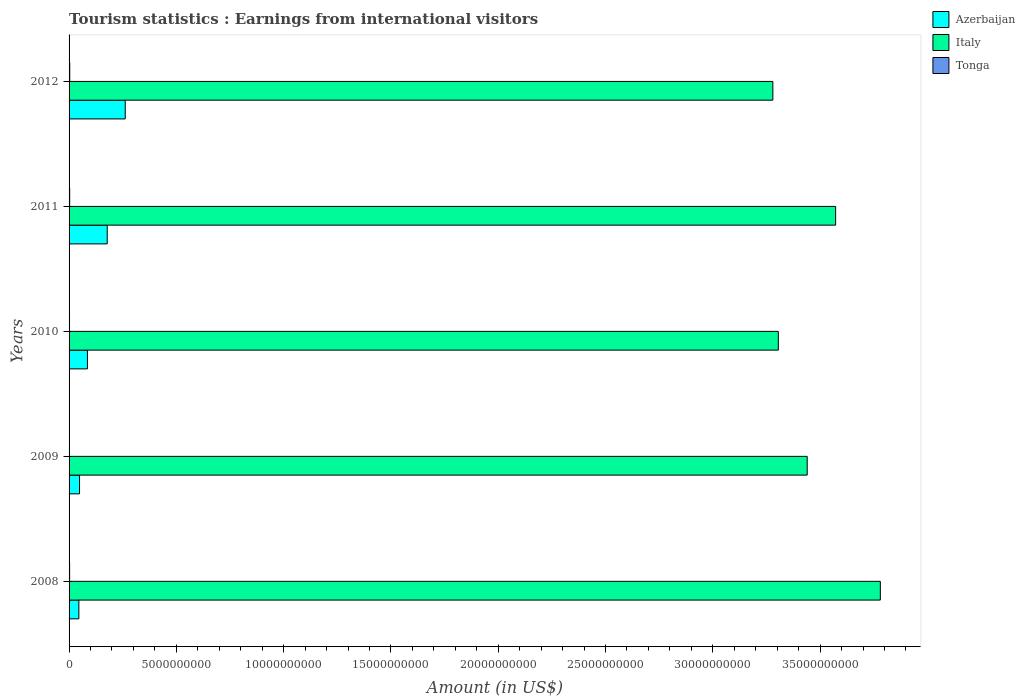How many different coloured bars are there?
Provide a succinct answer. 3. How many groups of bars are there?
Your answer should be very brief. 5. Are the number of bars per tick equal to the number of legend labels?
Provide a short and direct response. Yes. What is the label of the 4th group of bars from the top?
Make the answer very short. 2009. In how many cases, is the number of bars for a given year not equal to the number of legend labels?
Offer a very short reply. 0. What is the earnings from international visitors in Italy in 2010?
Ensure brevity in your answer.  3.31e+1. Across all years, what is the maximum earnings from international visitors in Italy?
Keep it short and to the point. 3.78e+1. Across all years, what is the minimum earnings from international visitors in Tonga?
Your answer should be compact. 1.91e+07. In which year was the earnings from international visitors in Italy maximum?
Your answer should be compact. 2008. What is the total earnings from international visitors in Azerbaijan in the graph?
Your response must be concise. 6.20e+09. What is the difference between the earnings from international visitors in Tonga in 2009 and that in 2010?
Your response must be concise. -1.30e+06. What is the difference between the earnings from international visitors in Azerbaijan in 2011 and the earnings from international visitors in Italy in 2008?
Provide a short and direct response. -3.60e+1. What is the average earnings from international visitors in Italy per year?
Give a very brief answer. 3.48e+1. In the year 2012, what is the difference between the earnings from international visitors in Italy and earnings from international visitors in Azerbaijan?
Provide a succinct answer. 3.02e+1. In how many years, is the earnings from international visitors in Tonga greater than 1000000000 US$?
Give a very brief answer. 0. What is the ratio of the earnings from international visitors in Tonga in 2010 to that in 2011?
Ensure brevity in your answer.  0.73. Is the earnings from international visitors in Tonga in 2009 less than that in 2010?
Your answer should be very brief. Yes. Is the difference between the earnings from international visitors in Italy in 2010 and 2011 greater than the difference between the earnings from international visitors in Azerbaijan in 2010 and 2011?
Your response must be concise. No. What is the difference between the highest and the second highest earnings from international visitors in Tonga?
Your response must be concise. 3.50e+06. What is the difference between the highest and the lowest earnings from international visitors in Azerbaijan?
Your response must be concise. 2.16e+09. Is the sum of the earnings from international visitors in Tonga in 2011 and 2012 greater than the maximum earnings from international visitors in Italy across all years?
Make the answer very short. No. What does the 1st bar from the top in 2009 represents?
Your response must be concise. Tonga. What does the 1st bar from the bottom in 2012 represents?
Make the answer very short. Azerbaijan. How many bars are there?
Provide a short and direct response. 15. Are all the bars in the graph horizontal?
Give a very brief answer. Yes. How many years are there in the graph?
Provide a short and direct response. 5. Are the values on the major ticks of X-axis written in scientific E-notation?
Make the answer very short. No. Does the graph contain any zero values?
Give a very brief answer. No. Where does the legend appear in the graph?
Your answer should be compact. Top right. How many legend labels are there?
Your answer should be very brief. 3. What is the title of the graph?
Your answer should be very brief. Tourism statistics : Earnings from international visitors. Does "Egypt, Arab Rep." appear as one of the legend labels in the graph?
Provide a succinct answer. No. What is the label or title of the Y-axis?
Offer a very short reply. Years. What is the Amount (in US$) of Azerbaijan in 2008?
Provide a succinct answer. 4.56e+08. What is the Amount (in US$) in Italy in 2008?
Your response must be concise. 3.78e+1. What is the Amount (in US$) in Tonga in 2008?
Offer a terse response. 2.51e+07. What is the Amount (in US$) in Azerbaijan in 2009?
Ensure brevity in your answer.  4.88e+08. What is the Amount (in US$) in Italy in 2009?
Your answer should be very brief. 3.44e+1. What is the Amount (in US$) of Tonga in 2009?
Provide a short and direct response. 1.91e+07. What is the Amount (in US$) of Azerbaijan in 2010?
Provide a succinct answer. 8.56e+08. What is the Amount (in US$) in Italy in 2010?
Make the answer very short. 3.31e+1. What is the Amount (in US$) of Tonga in 2010?
Your answer should be compact. 2.04e+07. What is the Amount (in US$) of Azerbaijan in 2011?
Offer a terse response. 1.78e+09. What is the Amount (in US$) in Italy in 2011?
Give a very brief answer. 3.57e+1. What is the Amount (in US$) of Tonga in 2011?
Provide a succinct answer. 2.78e+07. What is the Amount (in US$) in Azerbaijan in 2012?
Your answer should be very brief. 2.62e+09. What is the Amount (in US$) of Italy in 2012?
Offer a terse response. 3.28e+1. What is the Amount (in US$) of Tonga in 2012?
Your answer should be compact. 3.13e+07. Across all years, what is the maximum Amount (in US$) of Azerbaijan?
Ensure brevity in your answer.  2.62e+09. Across all years, what is the maximum Amount (in US$) in Italy?
Give a very brief answer. 3.78e+1. Across all years, what is the maximum Amount (in US$) in Tonga?
Make the answer very short. 3.13e+07. Across all years, what is the minimum Amount (in US$) in Azerbaijan?
Your answer should be compact. 4.56e+08. Across all years, what is the minimum Amount (in US$) of Italy?
Offer a terse response. 3.28e+1. Across all years, what is the minimum Amount (in US$) of Tonga?
Your response must be concise. 1.91e+07. What is the total Amount (in US$) of Azerbaijan in the graph?
Make the answer very short. 6.20e+09. What is the total Amount (in US$) in Italy in the graph?
Keep it short and to the point. 1.74e+11. What is the total Amount (in US$) in Tonga in the graph?
Your answer should be very brief. 1.24e+08. What is the difference between the Amount (in US$) in Azerbaijan in 2008 and that in 2009?
Give a very brief answer. -3.20e+07. What is the difference between the Amount (in US$) in Italy in 2008 and that in 2009?
Your response must be concise. 3.41e+09. What is the difference between the Amount (in US$) in Tonga in 2008 and that in 2009?
Provide a short and direct response. 6.00e+06. What is the difference between the Amount (in US$) of Azerbaijan in 2008 and that in 2010?
Provide a succinct answer. -4.00e+08. What is the difference between the Amount (in US$) of Italy in 2008 and that in 2010?
Your response must be concise. 4.75e+09. What is the difference between the Amount (in US$) in Tonga in 2008 and that in 2010?
Provide a short and direct response. 4.70e+06. What is the difference between the Amount (in US$) of Azerbaijan in 2008 and that in 2011?
Make the answer very short. -1.32e+09. What is the difference between the Amount (in US$) in Italy in 2008 and that in 2011?
Provide a short and direct response. 2.08e+09. What is the difference between the Amount (in US$) of Tonga in 2008 and that in 2011?
Provide a short and direct response. -2.70e+06. What is the difference between the Amount (in US$) of Azerbaijan in 2008 and that in 2012?
Offer a very short reply. -2.16e+09. What is the difference between the Amount (in US$) in Italy in 2008 and that in 2012?
Make the answer very short. 5.01e+09. What is the difference between the Amount (in US$) of Tonga in 2008 and that in 2012?
Make the answer very short. -6.20e+06. What is the difference between the Amount (in US$) in Azerbaijan in 2009 and that in 2010?
Provide a short and direct response. -3.68e+08. What is the difference between the Amount (in US$) of Italy in 2009 and that in 2010?
Offer a terse response. 1.35e+09. What is the difference between the Amount (in US$) in Tonga in 2009 and that in 2010?
Ensure brevity in your answer.  -1.30e+06. What is the difference between the Amount (in US$) of Azerbaijan in 2009 and that in 2011?
Make the answer very short. -1.29e+09. What is the difference between the Amount (in US$) of Italy in 2009 and that in 2011?
Give a very brief answer. -1.32e+09. What is the difference between the Amount (in US$) of Tonga in 2009 and that in 2011?
Provide a short and direct response. -8.70e+06. What is the difference between the Amount (in US$) in Azerbaijan in 2009 and that in 2012?
Provide a short and direct response. -2.13e+09. What is the difference between the Amount (in US$) of Italy in 2009 and that in 2012?
Your answer should be compact. 1.60e+09. What is the difference between the Amount (in US$) of Tonga in 2009 and that in 2012?
Your answer should be compact. -1.22e+07. What is the difference between the Amount (in US$) of Azerbaijan in 2010 and that in 2011?
Offer a very short reply. -9.22e+08. What is the difference between the Amount (in US$) in Italy in 2010 and that in 2011?
Provide a succinct answer. -2.67e+09. What is the difference between the Amount (in US$) in Tonga in 2010 and that in 2011?
Ensure brevity in your answer.  -7.40e+06. What is the difference between the Amount (in US$) of Azerbaijan in 2010 and that in 2012?
Give a very brief answer. -1.76e+09. What is the difference between the Amount (in US$) of Italy in 2010 and that in 2012?
Your answer should be compact. 2.55e+08. What is the difference between the Amount (in US$) in Tonga in 2010 and that in 2012?
Provide a succinct answer. -1.09e+07. What is the difference between the Amount (in US$) in Azerbaijan in 2011 and that in 2012?
Ensure brevity in your answer.  -8.39e+08. What is the difference between the Amount (in US$) of Italy in 2011 and that in 2012?
Your answer should be very brief. 2.93e+09. What is the difference between the Amount (in US$) in Tonga in 2011 and that in 2012?
Provide a succinct answer. -3.50e+06. What is the difference between the Amount (in US$) of Azerbaijan in 2008 and the Amount (in US$) of Italy in 2009?
Give a very brief answer. -3.39e+1. What is the difference between the Amount (in US$) of Azerbaijan in 2008 and the Amount (in US$) of Tonga in 2009?
Give a very brief answer. 4.37e+08. What is the difference between the Amount (in US$) in Italy in 2008 and the Amount (in US$) in Tonga in 2009?
Provide a succinct answer. 3.78e+1. What is the difference between the Amount (in US$) in Azerbaijan in 2008 and the Amount (in US$) in Italy in 2010?
Offer a very short reply. -3.26e+1. What is the difference between the Amount (in US$) in Azerbaijan in 2008 and the Amount (in US$) in Tonga in 2010?
Provide a succinct answer. 4.36e+08. What is the difference between the Amount (in US$) of Italy in 2008 and the Amount (in US$) of Tonga in 2010?
Keep it short and to the point. 3.78e+1. What is the difference between the Amount (in US$) in Azerbaijan in 2008 and the Amount (in US$) in Italy in 2011?
Give a very brief answer. -3.53e+1. What is the difference between the Amount (in US$) in Azerbaijan in 2008 and the Amount (in US$) in Tonga in 2011?
Offer a very short reply. 4.28e+08. What is the difference between the Amount (in US$) of Italy in 2008 and the Amount (in US$) of Tonga in 2011?
Your answer should be compact. 3.78e+1. What is the difference between the Amount (in US$) of Azerbaijan in 2008 and the Amount (in US$) of Italy in 2012?
Your answer should be very brief. -3.23e+1. What is the difference between the Amount (in US$) in Azerbaijan in 2008 and the Amount (in US$) in Tonga in 2012?
Your answer should be compact. 4.25e+08. What is the difference between the Amount (in US$) in Italy in 2008 and the Amount (in US$) in Tonga in 2012?
Ensure brevity in your answer.  3.78e+1. What is the difference between the Amount (in US$) of Azerbaijan in 2009 and the Amount (in US$) of Italy in 2010?
Offer a terse response. -3.26e+1. What is the difference between the Amount (in US$) of Azerbaijan in 2009 and the Amount (in US$) of Tonga in 2010?
Provide a short and direct response. 4.68e+08. What is the difference between the Amount (in US$) of Italy in 2009 and the Amount (in US$) of Tonga in 2010?
Keep it short and to the point. 3.44e+1. What is the difference between the Amount (in US$) of Azerbaijan in 2009 and the Amount (in US$) of Italy in 2011?
Make the answer very short. -3.52e+1. What is the difference between the Amount (in US$) in Azerbaijan in 2009 and the Amount (in US$) in Tonga in 2011?
Ensure brevity in your answer.  4.60e+08. What is the difference between the Amount (in US$) of Italy in 2009 and the Amount (in US$) of Tonga in 2011?
Your answer should be compact. 3.44e+1. What is the difference between the Amount (in US$) of Azerbaijan in 2009 and the Amount (in US$) of Italy in 2012?
Give a very brief answer. -3.23e+1. What is the difference between the Amount (in US$) of Azerbaijan in 2009 and the Amount (in US$) of Tonga in 2012?
Offer a terse response. 4.57e+08. What is the difference between the Amount (in US$) in Italy in 2009 and the Amount (in US$) in Tonga in 2012?
Offer a terse response. 3.44e+1. What is the difference between the Amount (in US$) of Azerbaijan in 2010 and the Amount (in US$) of Italy in 2011?
Your answer should be compact. -3.49e+1. What is the difference between the Amount (in US$) of Azerbaijan in 2010 and the Amount (in US$) of Tonga in 2011?
Make the answer very short. 8.28e+08. What is the difference between the Amount (in US$) in Italy in 2010 and the Amount (in US$) in Tonga in 2011?
Keep it short and to the point. 3.30e+1. What is the difference between the Amount (in US$) in Azerbaijan in 2010 and the Amount (in US$) in Italy in 2012?
Make the answer very short. -3.19e+1. What is the difference between the Amount (in US$) of Azerbaijan in 2010 and the Amount (in US$) of Tonga in 2012?
Offer a terse response. 8.25e+08. What is the difference between the Amount (in US$) in Italy in 2010 and the Amount (in US$) in Tonga in 2012?
Make the answer very short. 3.30e+1. What is the difference between the Amount (in US$) in Azerbaijan in 2011 and the Amount (in US$) in Italy in 2012?
Give a very brief answer. -3.10e+1. What is the difference between the Amount (in US$) of Azerbaijan in 2011 and the Amount (in US$) of Tonga in 2012?
Your answer should be compact. 1.75e+09. What is the difference between the Amount (in US$) of Italy in 2011 and the Amount (in US$) of Tonga in 2012?
Offer a terse response. 3.57e+1. What is the average Amount (in US$) of Azerbaijan per year?
Make the answer very short. 1.24e+09. What is the average Amount (in US$) in Italy per year?
Keep it short and to the point. 3.48e+1. What is the average Amount (in US$) in Tonga per year?
Ensure brevity in your answer.  2.47e+07. In the year 2008, what is the difference between the Amount (in US$) of Azerbaijan and Amount (in US$) of Italy?
Offer a terse response. -3.74e+1. In the year 2008, what is the difference between the Amount (in US$) of Azerbaijan and Amount (in US$) of Tonga?
Make the answer very short. 4.31e+08. In the year 2008, what is the difference between the Amount (in US$) of Italy and Amount (in US$) of Tonga?
Your response must be concise. 3.78e+1. In the year 2009, what is the difference between the Amount (in US$) of Azerbaijan and Amount (in US$) of Italy?
Provide a succinct answer. -3.39e+1. In the year 2009, what is the difference between the Amount (in US$) of Azerbaijan and Amount (in US$) of Tonga?
Your response must be concise. 4.69e+08. In the year 2009, what is the difference between the Amount (in US$) in Italy and Amount (in US$) in Tonga?
Provide a short and direct response. 3.44e+1. In the year 2010, what is the difference between the Amount (in US$) of Azerbaijan and Amount (in US$) of Italy?
Keep it short and to the point. -3.22e+1. In the year 2010, what is the difference between the Amount (in US$) of Azerbaijan and Amount (in US$) of Tonga?
Offer a very short reply. 8.36e+08. In the year 2010, what is the difference between the Amount (in US$) in Italy and Amount (in US$) in Tonga?
Offer a very short reply. 3.30e+1. In the year 2011, what is the difference between the Amount (in US$) of Azerbaijan and Amount (in US$) of Italy?
Make the answer very short. -3.39e+1. In the year 2011, what is the difference between the Amount (in US$) in Azerbaijan and Amount (in US$) in Tonga?
Provide a short and direct response. 1.75e+09. In the year 2011, what is the difference between the Amount (in US$) of Italy and Amount (in US$) of Tonga?
Your answer should be very brief. 3.57e+1. In the year 2012, what is the difference between the Amount (in US$) of Azerbaijan and Amount (in US$) of Italy?
Keep it short and to the point. -3.02e+1. In the year 2012, what is the difference between the Amount (in US$) in Azerbaijan and Amount (in US$) in Tonga?
Give a very brief answer. 2.59e+09. In the year 2012, what is the difference between the Amount (in US$) of Italy and Amount (in US$) of Tonga?
Make the answer very short. 3.28e+1. What is the ratio of the Amount (in US$) of Azerbaijan in 2008 to that in 2009?
Your response must be concise. 0.93. What is the ratio of the Amount (in US$) in Italy in 2008 to that in 2009?
Offer a terse response. 1.1. What is the ratio of the Amount (in US$) of Tonga in 2008 to that in 2009?
Keep it short and to the point. 1.31. What is the ratio of the Amount (in US$) of Azerbaijan in 2008 to that in 2010?
Keep it short and to the point. 0.53. What is the ratio of the Amount (in US$) of Italy in 2008 to that in 2010?
Give a very brief answer. 1.14. What is the ratio of the Amount (in US$) of Tonga in 2008 to that in 2010?
Provide a succinct answer. 1.23. What is the ratio of the Amount (in US$) of Azerbaijan in 2008 to that in 2011?
Your answer should be very brief. 0.26. What is the ratio of the Amount (in US$) in Italy in 2008 to that in 2011?
Your answer should be very brief. 1.06. What is the ratio of the Amount (in US$) in Tonga in 2008 to that in 2011?
Your response must be concise. 0.9. What is the ratio of the Amount (in US$) in Azerbaijan in 2008 to that in 2012?
Your answer should be very brief. 0.17. What is the ratio of the Amount (in US$) of Italy in 2008 to that in 2012?
Make the answer very short. 1.15. What is the ratio of the Amount (in US$) in Tonga in 2008 to that in 2012?
Make the answer very short. 0.8. What is the ratio of the Amount (in US$) of Azerbaijan in 2009 to that in 2010?
Provide a short and direct response. 0.57. What is the ratio of the Amount (in US$) in Italy in 2009 to that in 2010?
Provide a succinct answer. 1.04. What is the ratio of the Amount (in US$) in Tonga in 2009 to that in 2010?
Keep it short and to the point. 0.94. What is the ratio of the Amount (in US$) of Azerbaijan in 2009 to that in 2011?
Offer a terse response. 0.27. What is the ratio of the Amount (in US$) of Italy in 2009 to that in 2011?
Provide a succinct answer. 0.96. What is the ratio of the Amount (in US$) of Tonga in 2009 to that in 2011?
Your answer should be very brief. 0.69. What is the ratio of the Amount (in US$) of Azerbaijan in 2009 to that in 2012?
Give a very brief answer. 0.19. What is the ratio of the Amount (in US$) of Italy in 2009 to that in 2012?
Provide a succinct answer. 1.05. What is the ratio of the Amount (in US$) in Tonga in 2009 to that in 2012?
Your answer should be very brief. 0.61. What is the ratio of the Amount (in US$) in Azerbaijan in 2010 to that in 2011?
Ensure brevity in your answer.  0.48. What is the ratio of the Amount (in US$) in Italy in 2010 to that in 2011?
Offer a terse response. 0.93. What is the ratio of the Amount (in US$) in Tonga in 2010 to that in 2011?
Offer a terse response. 0.73. What is the ratio of the Amount (in US$) in Azerbaijan in 2010 to that in 2012?
Provide a short and direct response. 0.33. What is the ratio of the Amount (in US$) of Italy in 2010 to that in 2012?
Your response must be concise. 1.01. What is the ratio of the Amount (in US$) of Tonga in 2010 to that in 2012?
Your answer should be very brief. 0.65. What is the ratio of the Amount (in US$) in Azerbaijan in 2011 to that in 2012?
Ensure brevity in your answer.  0.68. What is the ratio of the Amount (in US$) in Italy in 2011 to that in 2012?
Offer a terse response. 1.09. What is the ratio of the Amount (in US$) in Tonga in 2011 to that in 2012?
Give a very brief answer. 0.89. What is the difference between the highest and the second highest Amount (in US$) of Azerbaijan?
Your response must be concise. 8.39e+08. What is the difference between the highest and the second highest Amount (in US$) of Italy?
Provide a short and direct response. 2.08e+09. What is the difference between the highest and the second highest Amount (in US$) of Tonga?
Offer a terse response. 3.50e+06. What is the difference between the highest and the lowest Amount (in US$) in Azerbaijan?
Provide a succinct answer. 2.16e+09. What is the difference between the highest and the lowest Amount (in US$) in Italy?
Your answer should be compact. 5.01e+09. What is the difference between the highest and the lowest Amount (in US$) in Tonga?
Offer a terse response. 1.22e+07. 